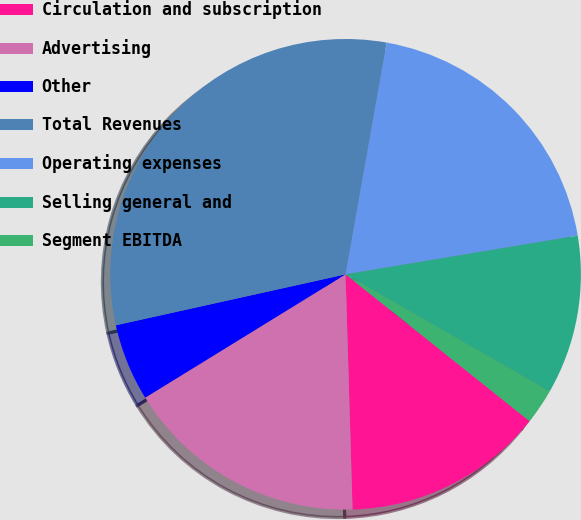Convert chart. <chart><loc_0><loc_0><loc_500><loc_500><pie_chart><fcel>Circulation and subscription<fcel>Advertising<fcel>Other<fcel>Total Revenues<fcel>Operating expenses<fcel>Selling general and<fcel>Segment EBITDA<nl><fcel>13.81%<fcel>16.69%<fcel>5.31%<fcel>31.27%<fcel>19.58%<fcel>10.92%<fcel>2.43%<nl></chart> 